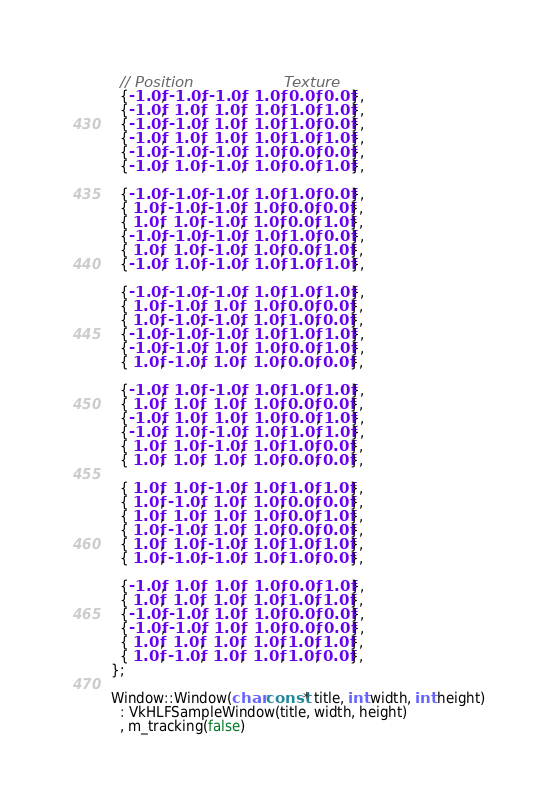<code> <loc_0><loc_0><loc_500><loc_500><_C++_>  // Position                   Texture
  {-1.0f, -1.0f, -1.0f,  1.0f, 0.0f, 0.0f},
  {-1.0f,  1.0f,  1.0f,  1.0f, 1.0f, 1.0f},
  {-1.0f, -1.0f,  1.0f,  1.0f, 1.0f, 0.0f},
  {-1.0f,  1.0f,  1.0f,  1.0f, 1.0f, 1.0f},
  {-1.0f, -1.0f, -1.0f,  1.0f, 0.0f, 0.0f},
  {-1.0f,  1.0f, -1.0f,  1.0f, 0.0f, 1.0f},

  {-1.0f, -1.0f, -1.0f,  1.0f, 1.0f, 0.0f},
  { 1.0f, -1.0f, -1.0f,  1.0f, 0.0f, 0.0f},
  { 1.0f,  1.0f, -1.0f,  1.0f, 0.0f, 1.0f},
  {-1.0f, -1.0f, -1.0f,  1.0f, 1.0f, 0.0f},
  { 1.0f,  1.0f, -1.0f,  1.0f, 0.0f, 1.0f},
  {-1.0f,  1.0f, -1.0f,  1.0f, 1.0f, 1.0f},

  {-1.0f, -1.0f, -1.0f,  1.0f, 1.0f, 1.0f},
  { 1.0f, -1.0f,  1.0f,  1.0f, 0.0f, 0.0f},
  { 1.0f, -1.0f, -1.0f,  1.0f, 1.0f, 0.0f},
  {-1.0f, -1.0f, -1.0f,  1.0f, 1.0f, 1.0f},
  {-1.0f, -1.0f,  1.0f,  1.0f, 0.0f, 1.0f},
  { 1.0f, -1.0f,  1.0f,  1.0f, 0.0f, 0.0f},

  {-1.0f,  1.0f, -1.0f,  1.0f, 1.0f, 1.0f},
  { 1.0f,  1.0f,  1.0f,  1.0f, 0.0f, 0.0f},
  {-1.0f,  1.0f,  1.0f,  1.0f, 0.0f, 1.0f},
  {-1.0f,  1.0f, -1.0f,  1.0f, 1.0f, 1.0f},
  { 1.0f,  1.0f, -1.0f,  1.0f, 1.0f, 0.0f},
  { 1.0f,  1.0f,  1.0f,  1.0f, 0.0f, 0.0f},

  { 1.0f,  1.0f, -1.0f,  1.0f, 1.0f, 1.0f},
  { 1.0f, -1.0f,  1.0f,  1.0f, 0.0f, 0.0f},
  { 1.0f,  1.0f,  1.0f,  1.0f, 0.0f, 1.0f},
  { 1.0f, -1.0f,  1.0f,  1.0f, 0.0f, 0.0f},
  { 1.0f,  1.0f, -1.0f,  1.0f, 1.0f, 1.0f},
  { 1.0f, -1.0f, -1.0f,  1.0f, 1.0f, 0.0f},

  {-1.0f,  1.0f,  1.0f,  1.0f, 0.0f, 1.0f},
  { 1.0f,  1.0f,  1.0f,  1.0f, 1.0f, 1.0f},
  {-1.0f, -1.0f,  1.0f,  1.0f, 0.0f, 0.0f},
  {-1.0f, -1.0f,  1.0f,  1.0f, 0.0f, 0.0f},
  { 1.0f,  1.0f,  1.0f,  1.0f, 1.0f, 1.0f},
  { 1.0f, -1.0f,  1.0f,  1.0f, 1.0f, 0.0f},
};

Window::Window(char const* title, int width, int height)
  : VkHLFSampleWindow(title, width, height)
  , m_tracking(false)</code> 